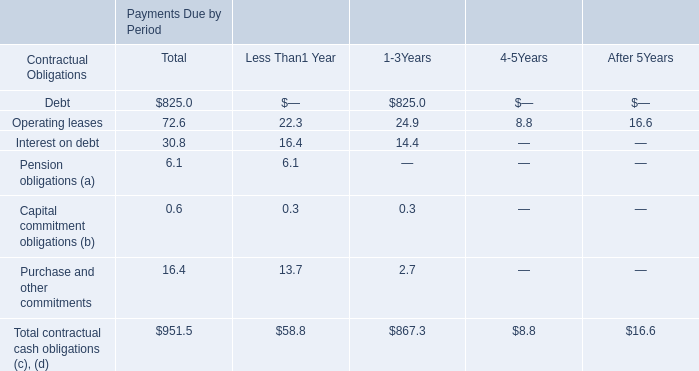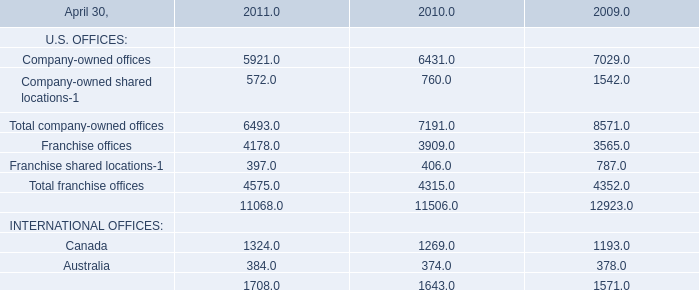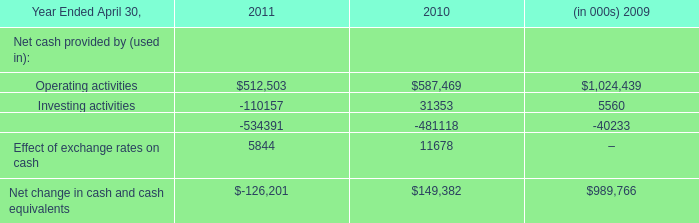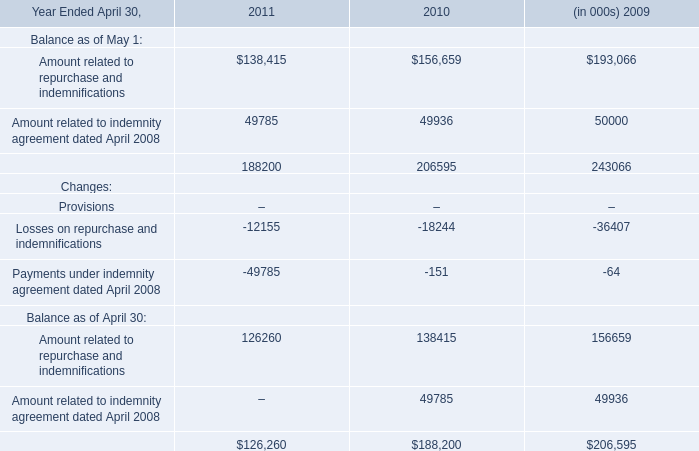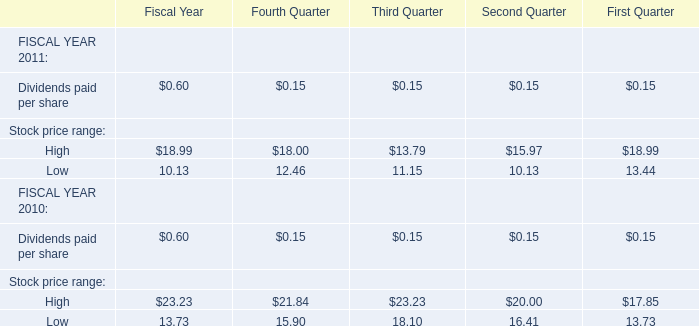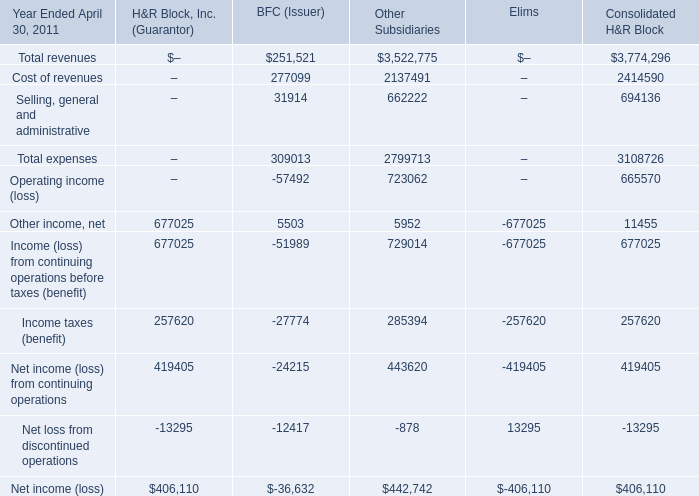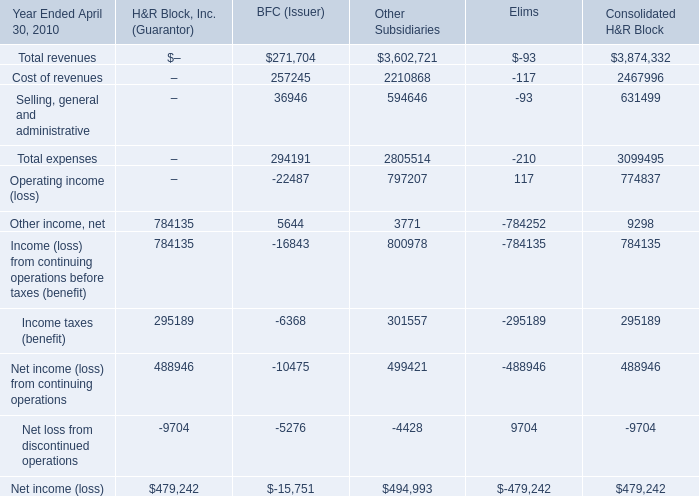In which section the sum of Other income, net has the highest value? 
Answer: H&R Block, Inc. (Guarantor). 